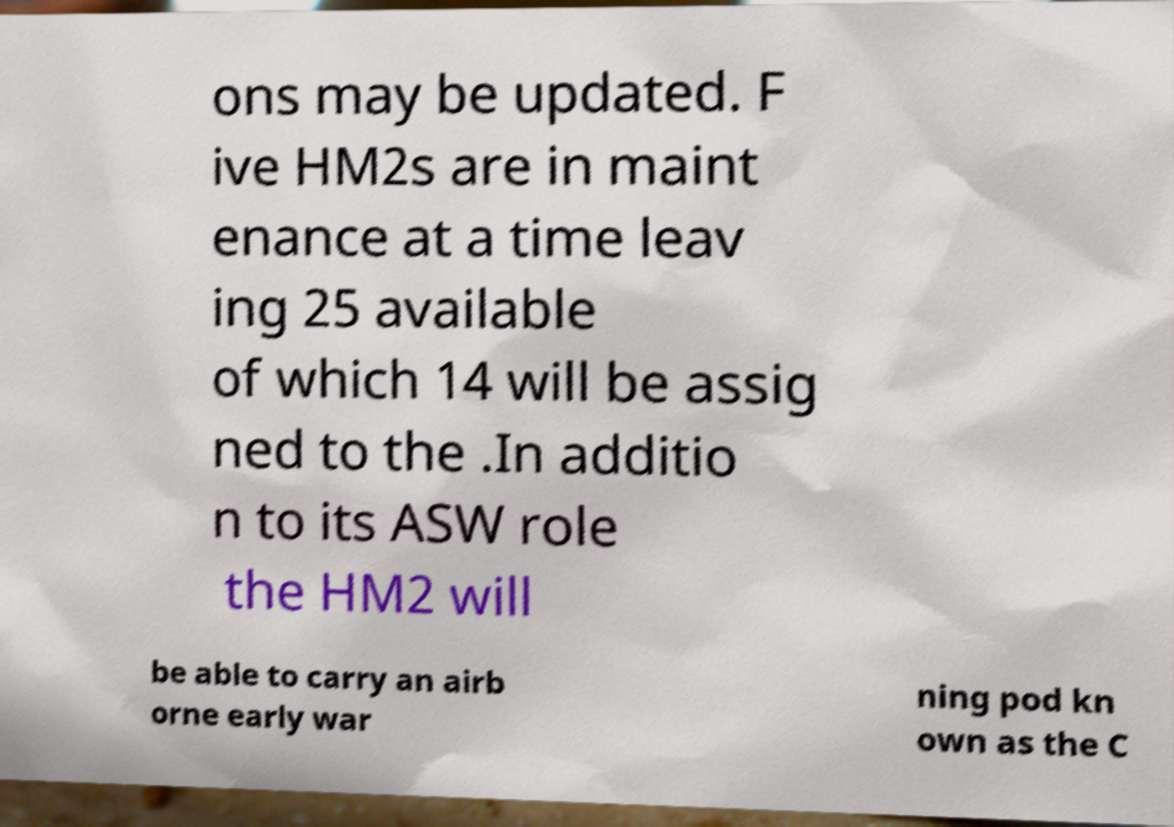For documentation purposes, I need the text within this image transcribed. Could you provide that? ons may be updated. F ive HM2s are in maint enance at a time leav ing 25 available of which 14 will be assig ned to the .In additio n to its ASW role the HM2 will be able to carry an airb orne early war ning pod kn own as the C 